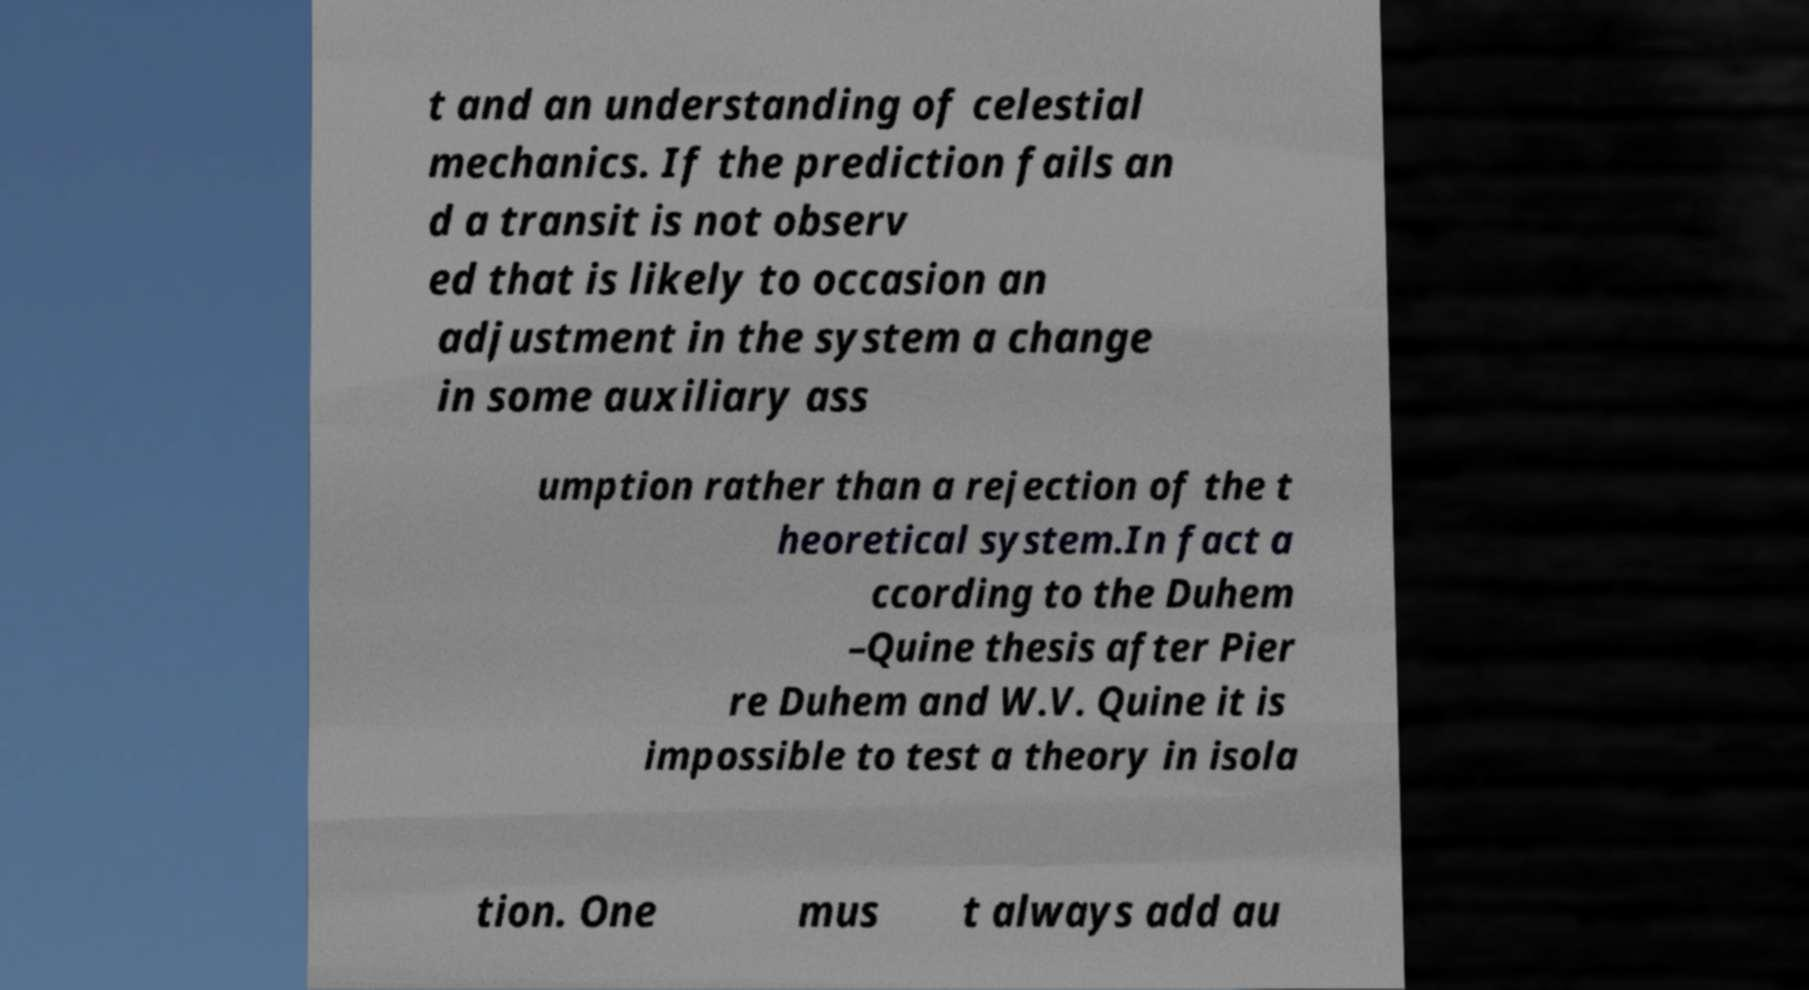Could you assist in decoding the text presented in this image and type it out clearly? t and an understanding of celestial mechanics. If the prediction fails an d a transit is not observ ed that is likely to occasion an adjustment in the system a change in some auxiliary ass umption rather than a rejection of the t heoretical system.In fact a ccording to the Duhem –Quine thesis after Pier re Duhem and W.V. Quine it is impossible to test a theory in isola tion. One mus t always add au 